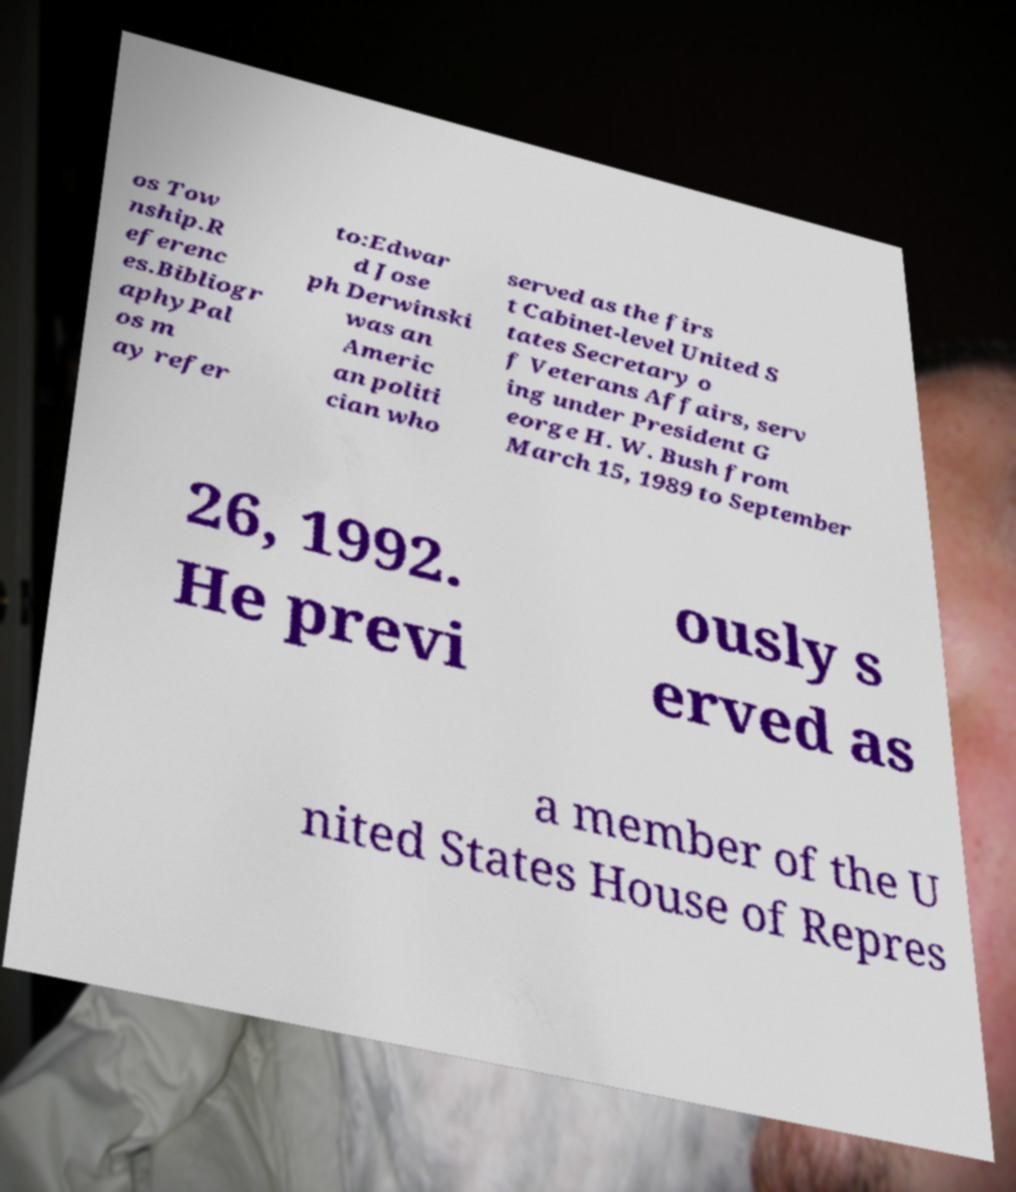I need the written content from this picture converted into text. Can you do that? os Tow nship.R eferenc es.Bibliogr aphyPal os m ay refer to:Edwar d Jose ph Derwinski was an Americ an politi cian who served as the firs t Cabinet-level United S tates Secretary o f Veterans Affairs, serv ing under President G eorge H. W. Bush from March 15, 1989 to September 26, 1992. He previ ously s erved as a member of the U nited States House of Repres 